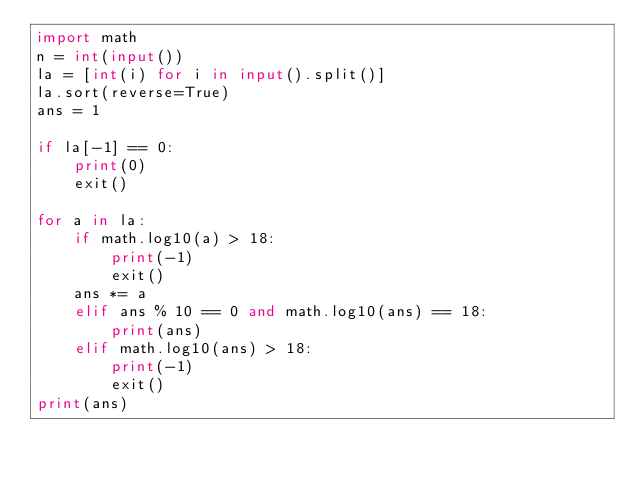<code> <loc_0><loc_0><loc_500><loc_500><_Python_>import math
n = int(input())
la = [int(i) for i in input().split()]
la.sort(reverse=True)
ans = 1

if la[-1] == 0:
    print(0)
    exit()

for a in la:
    if math.log10(a) > 18:
        print(-1)
        exit()
    ans *= a
    elif ans % 10 == 0 and math.log10(ans) == 18:
        print(ans)
    elif math.log10(ans) > 18:
        print(-1)
        exit()
print(ans)</code> 